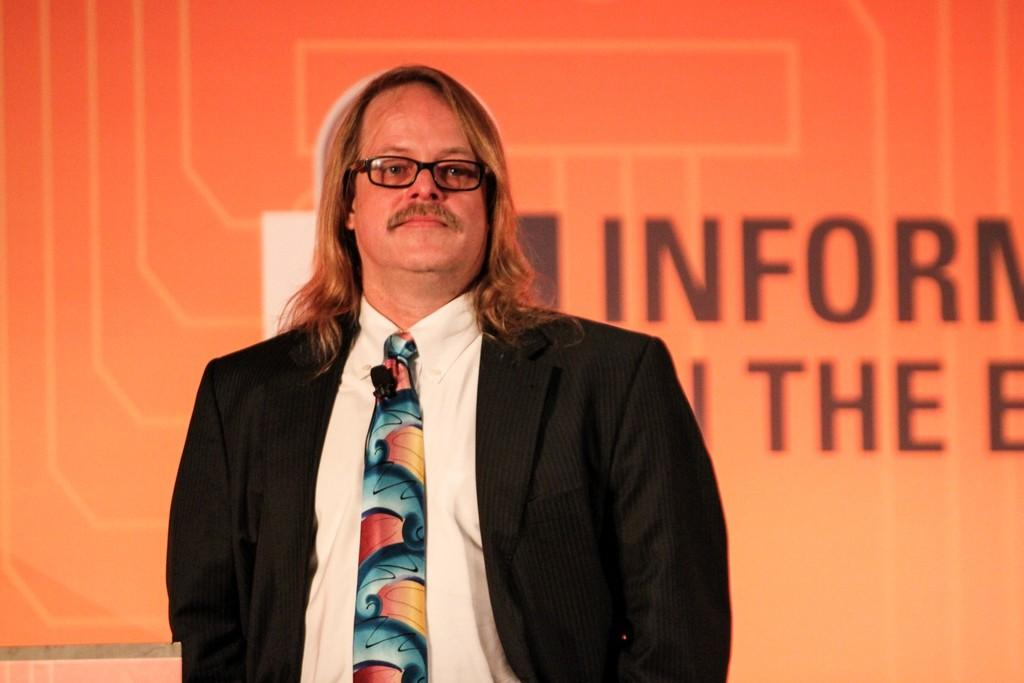What is the main subject of the image? There is a man standing in the image. What can be seen in the background of the image? There is a screen in the background of the image. What is the title of the movie being shown on the screen in the image? There is no information about a movie or its title in the image. What is the plot of the story being displayed on the screen in the image? There is no information about a story or its plot in the image. 